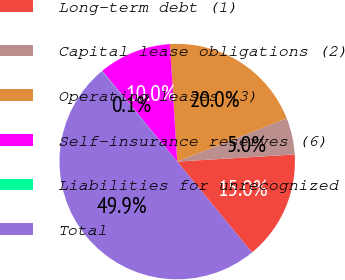Convert chart to OTSL. <chart><loc_0><loc_0><loc_500><loc_500><pie_chart><fcel>Long-term debt (1)<fcel>Capital lease obligations (2)<fcel>Operating leases (3)<fcel>Self-insurance reserves (6)<fcel>Liabilities for unrecognized<fcel>Total<nl><fcel>15.0%<fcel>5.03%<fcel>19.99%<fcel>10.02%<fcel>0.05%<fcel>49.9%<nl></chart> 